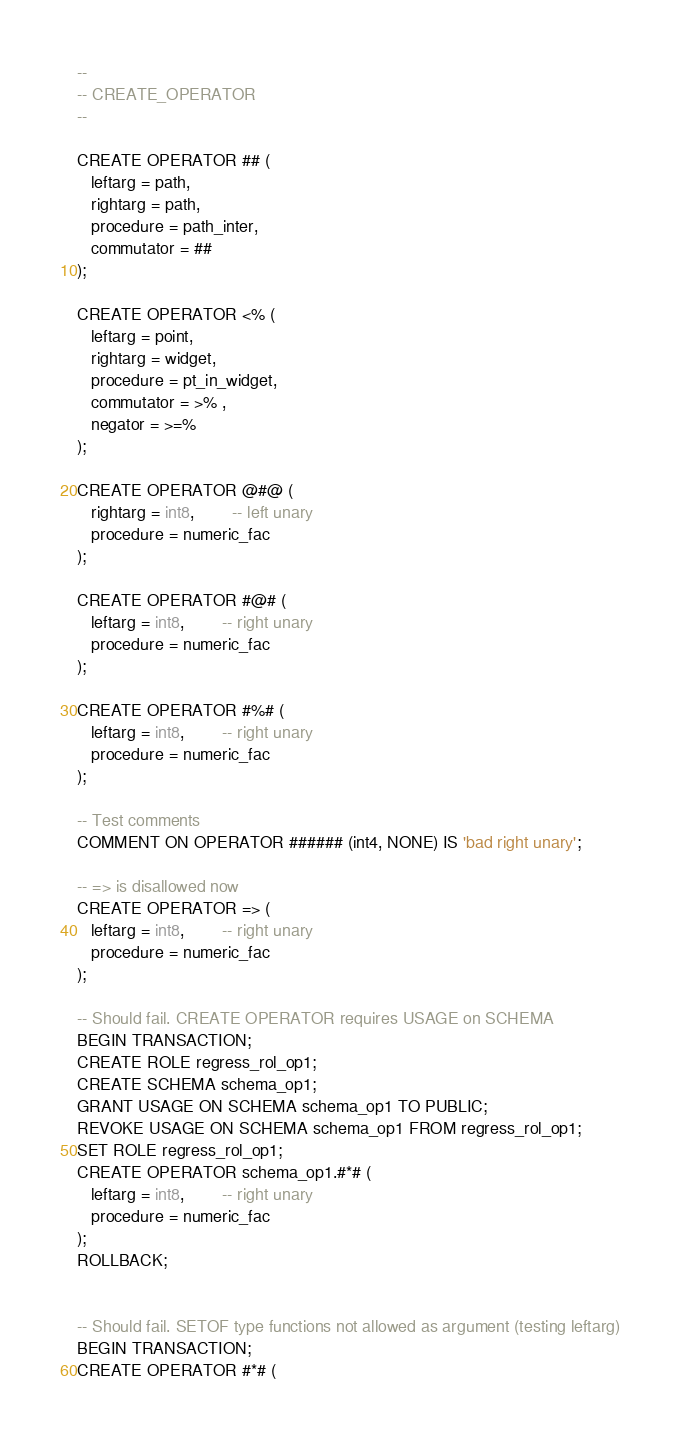<code> <loc_0><loc_0><loc_500><loc_500><_SQL_>--
-- CREATE_OPERATOR
--

CREATE OPERATOR ## (
   leftarg = path,
   rightarg = path,
   procedure = path_inter,
   commutator = ##
);

CREATE OPERATOR <% (
   leftarg = point,
   rightarg = widget,
   procedure = pt_in_widget,
   commutator = >% ,
   negator = >=%
);

CREATE OPERATOR @#@ (
   rightarg = int8,		-- left unary
   procedure = numeric_fac
);

CREATE OPERATOR #@# (
   leftarg = int8,		-- right unary
   procedure = numeric_fac
);

CREATE OPERATOR #%# (
   leftarg = int8,		-- right unary
   procedure = numeric_fac
);

-- Test comments
COMMENT ON OPERATOR ###### (int4, NONE) IS 'bad right unary';

-- => is disallowed now
CREATE OPERATOR => (
   leftarg = int8,		-- right unary
   procedure = numeric_fac
);

-- Should fail. CREATE OPERATOR requires USAGE on SCHEMA
BEGIN TRANSACTION;
CREATE ROLE regress_rol_op1;
CREATE SCHEMA schema_op1;
GRANT USAGE ON SCHEMA schema_op1 TO PUBLIC;
REVOKE USAGE ON SCHEMA schema_op1 FROM regress_rol_op1;
SET ROLE regress_rol_op1;
CREATE OPERATOR schema_op1.#*# (
   leftarg = int8,		-- right unary
   procedure = numeric_fac
);
ROLLBACK;


-- Should fail. SETOF type functions not allowed as argument (testing leftarg)
BEGIN TRANSACTION;
CREATE OPERATOR #*# (</code> 